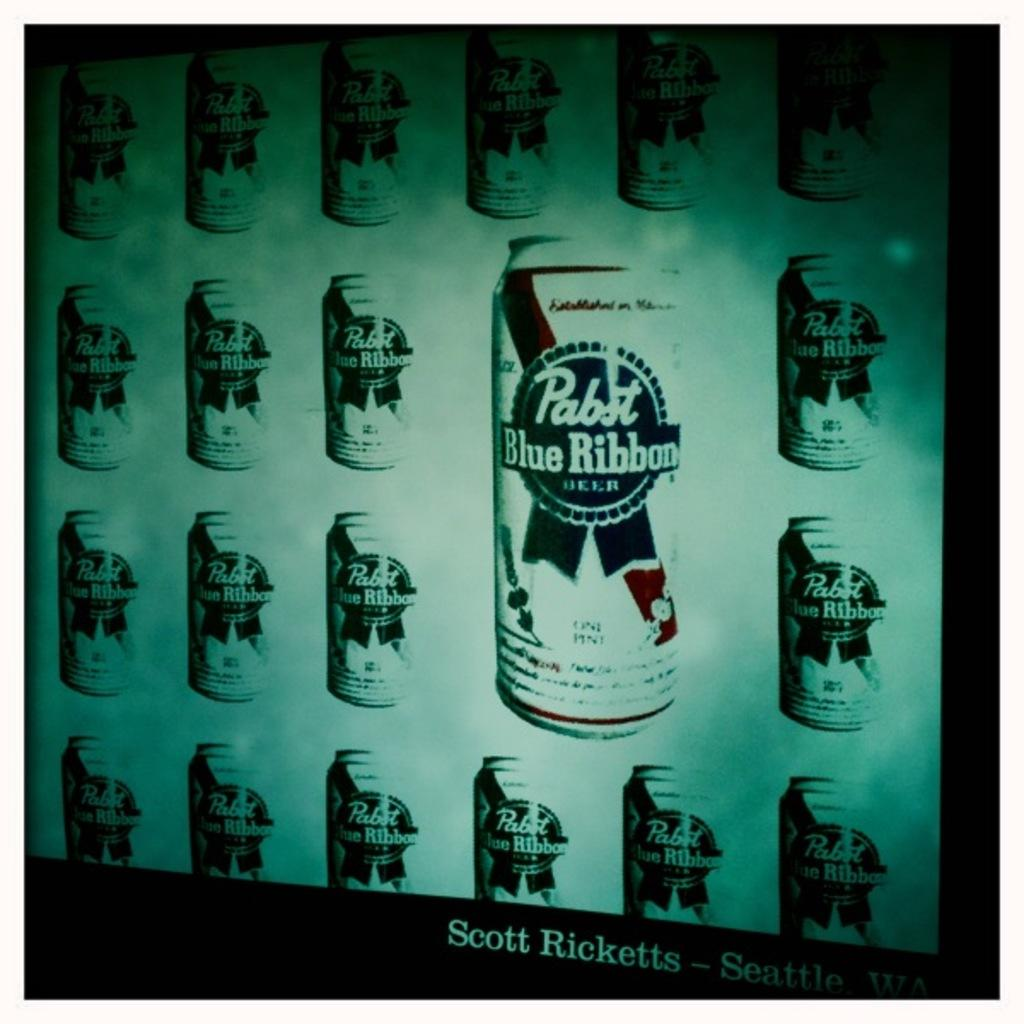<image>
Give a short and clear explanation of the subsequent image. A screen shows a whole bunch of cans of Pabst Blue Ribbon Beer. 